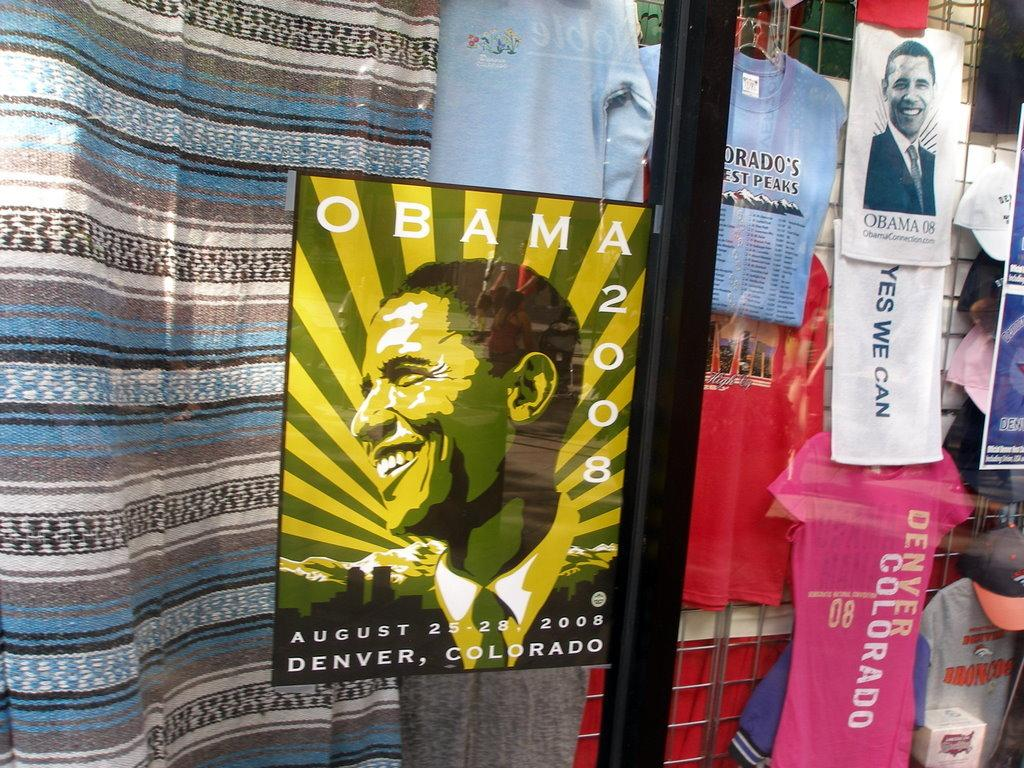<image>
Relay a brief, clear account of the picture shown. A yellow and green poster image with Obama 2008 on it. 